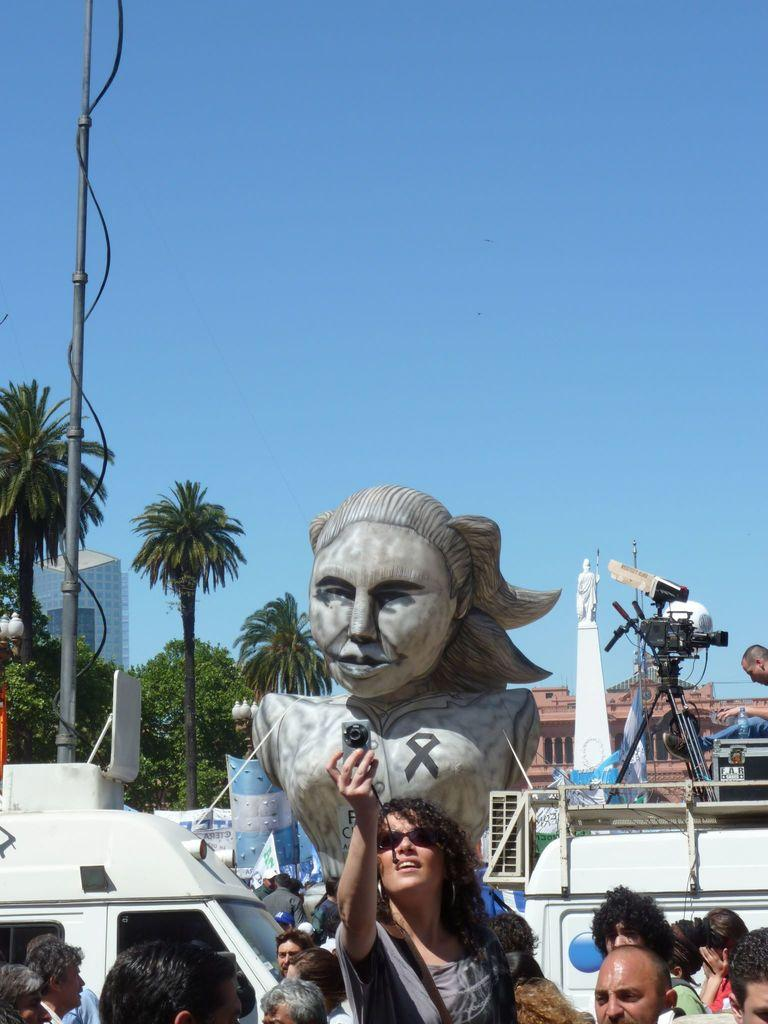What is the main subject in the image? There is a statue in the image. What else can be seen in the image besides the statue? There is a motor vehicle, persons standing on the road, a woman holding a camera, buildings, trees, a camera, tripods, and the sky visible in the image. What are the persons on the road doing? The persons on the road are standing. What is the woman holding in the image? The woman is holding a camera. What are the tripods used for in the image? The tripods are used to support the cameras. What type of skin is visible on the statue in the image? The statue is made of a material that does not have skin, so this question cannot be answered. Can you tell me how many yaks are present in the image? There are no yaks present in the image. 